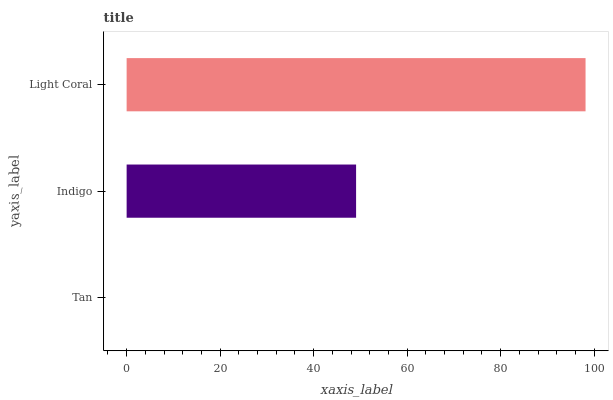Is Tan the minimum?
Answer yes or no. Yes. Is Light Coral the maximum?
Answer yes or no. Yes. Is Indigo the minimum?
Answer yes or no. No. Is Indigo the maximum?
Answer yes or no. No. Is Indigo greater than Tan?
Answer yes or no. Yes. Is Tan less than Indigo?
Answer yes or no. Yes. Is Tan greater than Indigo?
Answer yes or no. No. Is Indigo less than Tan?
Answer yes or no. No. Is Indigo the high median?
Answer yes or no. Yes. Is Indigo the low median?
Answer yes or no. Yes. Is Tan the high median?
Answer yes or no. No. Is Tan the low median?
Answer yes or no. No. 